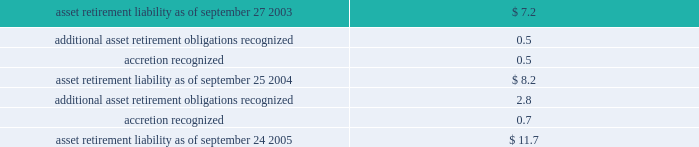Notes to consolidated financial statements ( continued ) note 1 2014summary of significant accounting policies ( continued ) asset retirement obligations the company records obligations associated with the retirement of tangible long-lived assets and the associated asset retirement costs in accordance with sfas no .
143 , accounting for asset retirement obligations .
The company reviews legal obligations associated with the retirement of long-lived assets that result from the acquisition , construction , development and/or normal use of the assets .
If it is determined that a legal obligation exists , the fair value of the liability for an asset retirement obligation is recognized in the period in which it is incurred if a reasonable estimate of fair value can be made .
The fair value of the liability is added to the carrying amount of the associated asset and this additional carrying amount is depreciated over the life of the asset .
The difference between the gross expected future cash flow and its present value is accreted over the life of the related lease as an operating expense .
All of the company 2019s existing asset retirement obligations are associated with commitments to return property subject to operating leases to original condition upon lease termination .
The table reconciles changes in the company 2019s asset retirement liabilities for fiscal 2004 and 2005 ( in millions ) : .
Cumulative effects of accounting changes in 2003 , the company recognized a net favorable cumulative effect type adjustment of approximately $ 1 million from the adoption of sfas no .
150 , accounting for certain financial instruments with characteristic of both liabilities and equity and sfas no .
143 .
Long-lived assets including goodwill and other acquired intangible assets the company reviews property , plant , and equipment and certain identifiable intangibles , excluding goodwill , for impairment whenever events or changes in circumstances indicate the carrying amount of an asset may not be recoverable .
Recoverability of these assets is measured by comparison of its carrying amount to future undiscounted cash flows the assets are expected to generate .
If property , plant , and equipment and certain identifiable intangibles are considered to be impaired , the impairment to be recognized equals the amount by which the carrying value of the assets exceeds its fair market value .
For the three fiscal years ended september 24 , 2005 , the company had no material impairment of its long-lived assets , except for the impairment of certain assets in connection with the restructuring actions described in note 5 of these notes to consolidated financial statements .
Sfas no .
142 , goodwill and other intangible assets requires that goodwill and intangible assets with indefinite useful lives should not be amortized but rather be tested for impairment at least annually or sooner whenever events or changes in circumstances indicate that they may be impaired .
The company performs its goodwill impairment tests on or about august 30 of each year .
The company did not recognize any goodwill or intangible asset impairment charges in 2005 , 2004 , or 2003 .
The company established reporting units based on its current reporting structure .
For purposes of testing goodwill for .
What was the change in asset retirement liability between september 2004 and 2005 , in millions? 
Computations: (11.7 - 8.2)
Answer: 3.5. 